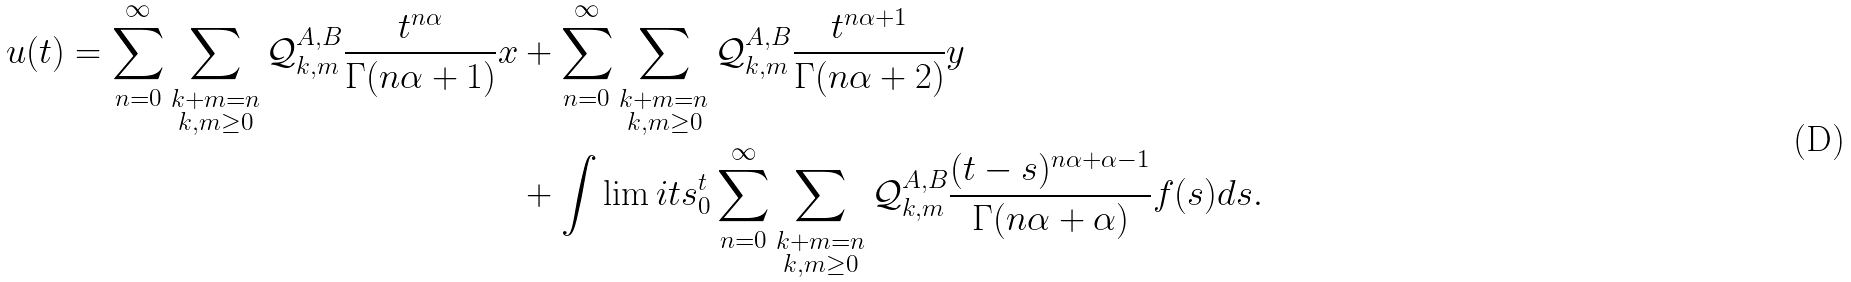<formula> <loc_0><loc_0><loc_500><loc_500>u ( t ) = \sum _ { n = 0 } ^ { \infty } \sum _ { \substack { k + m = n \\ k , m \geq 0 } } \mathcal { Q } ^ { A , B } _ { k , m } \frac { t ^ { n \alpha } } { \Gamma ( n \alpha + 1 ) } x & + \sum _ { n = 0 } ^ { \infty } \sum _ { \substack { k + m = n \\ k , m \geq 0 } } \mathcal { Q } ^ { A , B } _ { k , m } \frac { t ^ { n \alpha + 1 } } { \Gamma ( n \alpha + 2 ) } y \\ & + \int \lim i t s _ { 0 } ^ { t } \sum _ { n = 0 } ^ { \infty } \sum _ { \substack { k + m = n \\ k , m \geq 0 } } \mathcal { Q } ^ { A , B } _ { k , m } \frac { ( t - s ) ^ { n \alpha + \alpha - 1 } } { \Gamma ( n \alpha + \alpha ) } f ( s ) d s .</formula> 